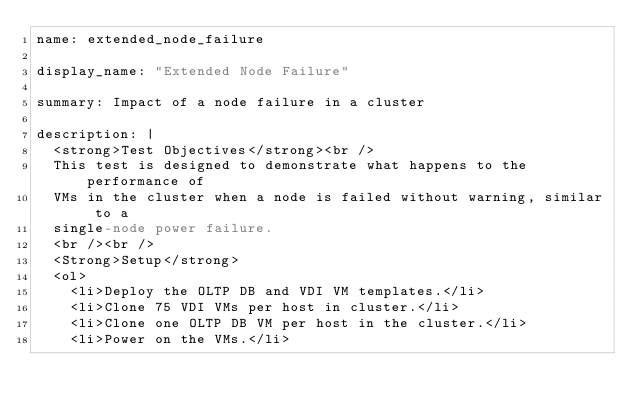<code> <loc_0><loc_0><loc_500><loc_500><_YAML_>name: extended_node_failure

display_name: "Extended Node Failure"

summary: Impact of a node failure in a cluster

description: |
  <strong>Test Objectives</strong><br />
  This test is designed to demonstrate what happens to the performance of
  VMs in the cluster when a node is failed without warning, similar to a
  single-node power failure.
  <br /><br />
  <Strong>Setup</strong>
  <ol>
    <li>Deploy the OLTP DB and VDI VM templates.</li>
    <li>Clone 75 VDI VMs per host in cluster.</li>
    <li>Clone one OLTP DB VM per host in the cluster.</li>
    <li>Power on the VMs.</li></code> 